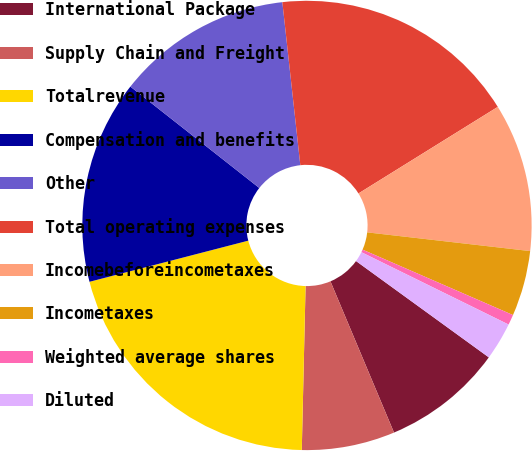Convert chart to OTSL. <chart><loc_0><loc_0><loc_500><loc_500><pie_chart><fcel>International Package<fcel>Supply Chain and Freight<fcel>Totalrevenue<fcel>Compensation and benefits<fcel>Other<fcel>Total operating expenses<fcel>Incomebeforeincometaxes<fcel>Incometaxes<fcel>Weighted average shares<fcel>Diluted<nl><fcel>8.68%<fcel>6.7%<fcel>20.6%<fcel>14.64%<fcel>12.65%<fcel>17.9%<fcel>10.67%<fcel>4.71%<fcel>0.74%<fcel>2.72%<nl></chart> 